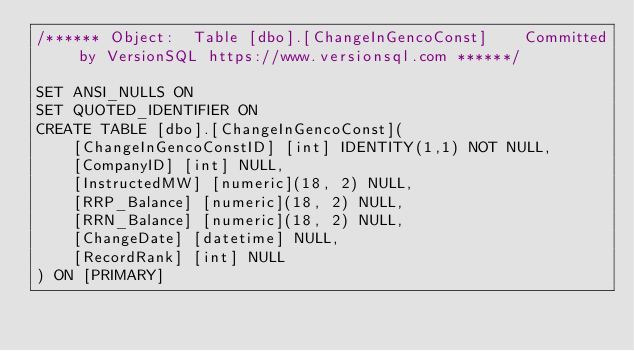<code> <loc_0><loc_0><loc_500><loc_500><_SQL_>/****** Object:  Table [dbo].[ChangeInGencoConst]    Committed by VersionSQL https://www.versionsql.com ******/

SET ANSI_NULLS ON
SET QUOTED_IDENTIFIER ON
CREATE TABLE [dbo].[ChangeInGencoConst](
	[ChangeInGencoConstID] [int] IDENTITY(1,1) NOT NULL,
	[CompanyID] [int] NULL,
	[InstructedMW] [numeric](18, 2) NULL,
	[RRP_Balance] [numeric](18, 2) NULL,
	[RRN_Balance] [numeric](18, 2) NULL,
	[ChangeDate] [datetime] NULL,
	[RecordRank] [int] NULL
) ON [PRIMARY]

</code> 